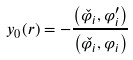<formula> <loc_0><loc_0><loc_500><loc_500>y _ { 0 } ( r ) = - \frac { \left ( \check { \varphi _ { i } } , \varphi _ { i } ^ { \prime } \right ) } { \left ( \check { \varphi _ { i } } , \varphi _ { i } \right ) }</formula> 